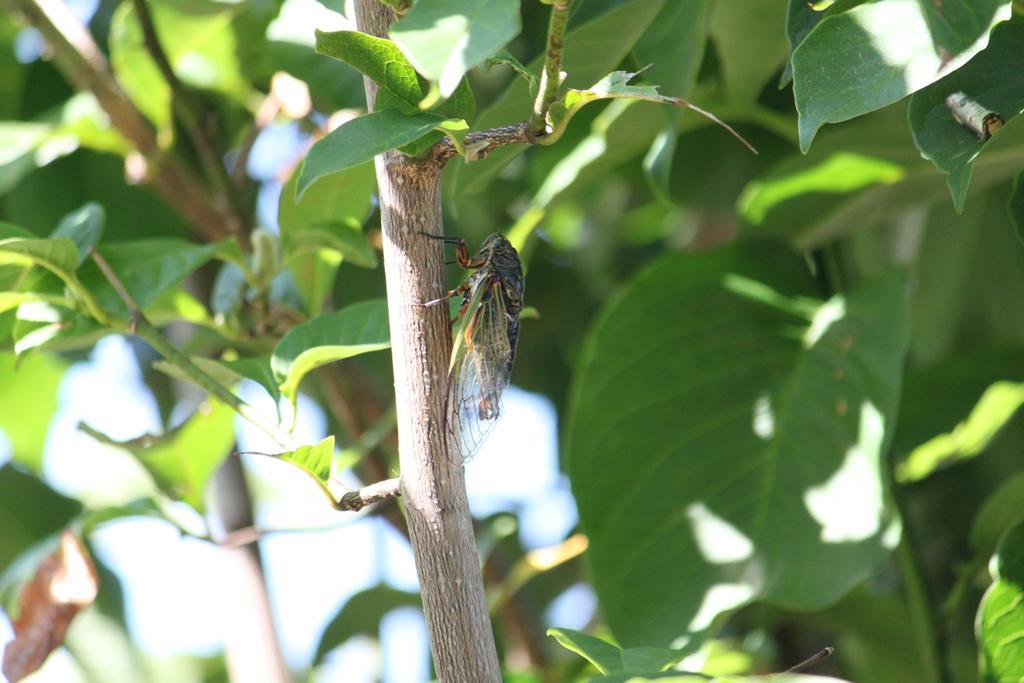Could you give a brief overview of what you see in this image? This picture shows a fly on the branch of a tree. we see leaves. 